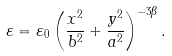<formula> <loc_0><loc_0><loc_500><loc_500>\varepsilon = \varepsilon _ { 0 } \left ( \frac { x ^ { 2 } } { b ^ { 2 } } + \frac { y ^ { 2 } } { a ^ { 2 } } \right ) ^ { - 3 \beta } .</formula> 